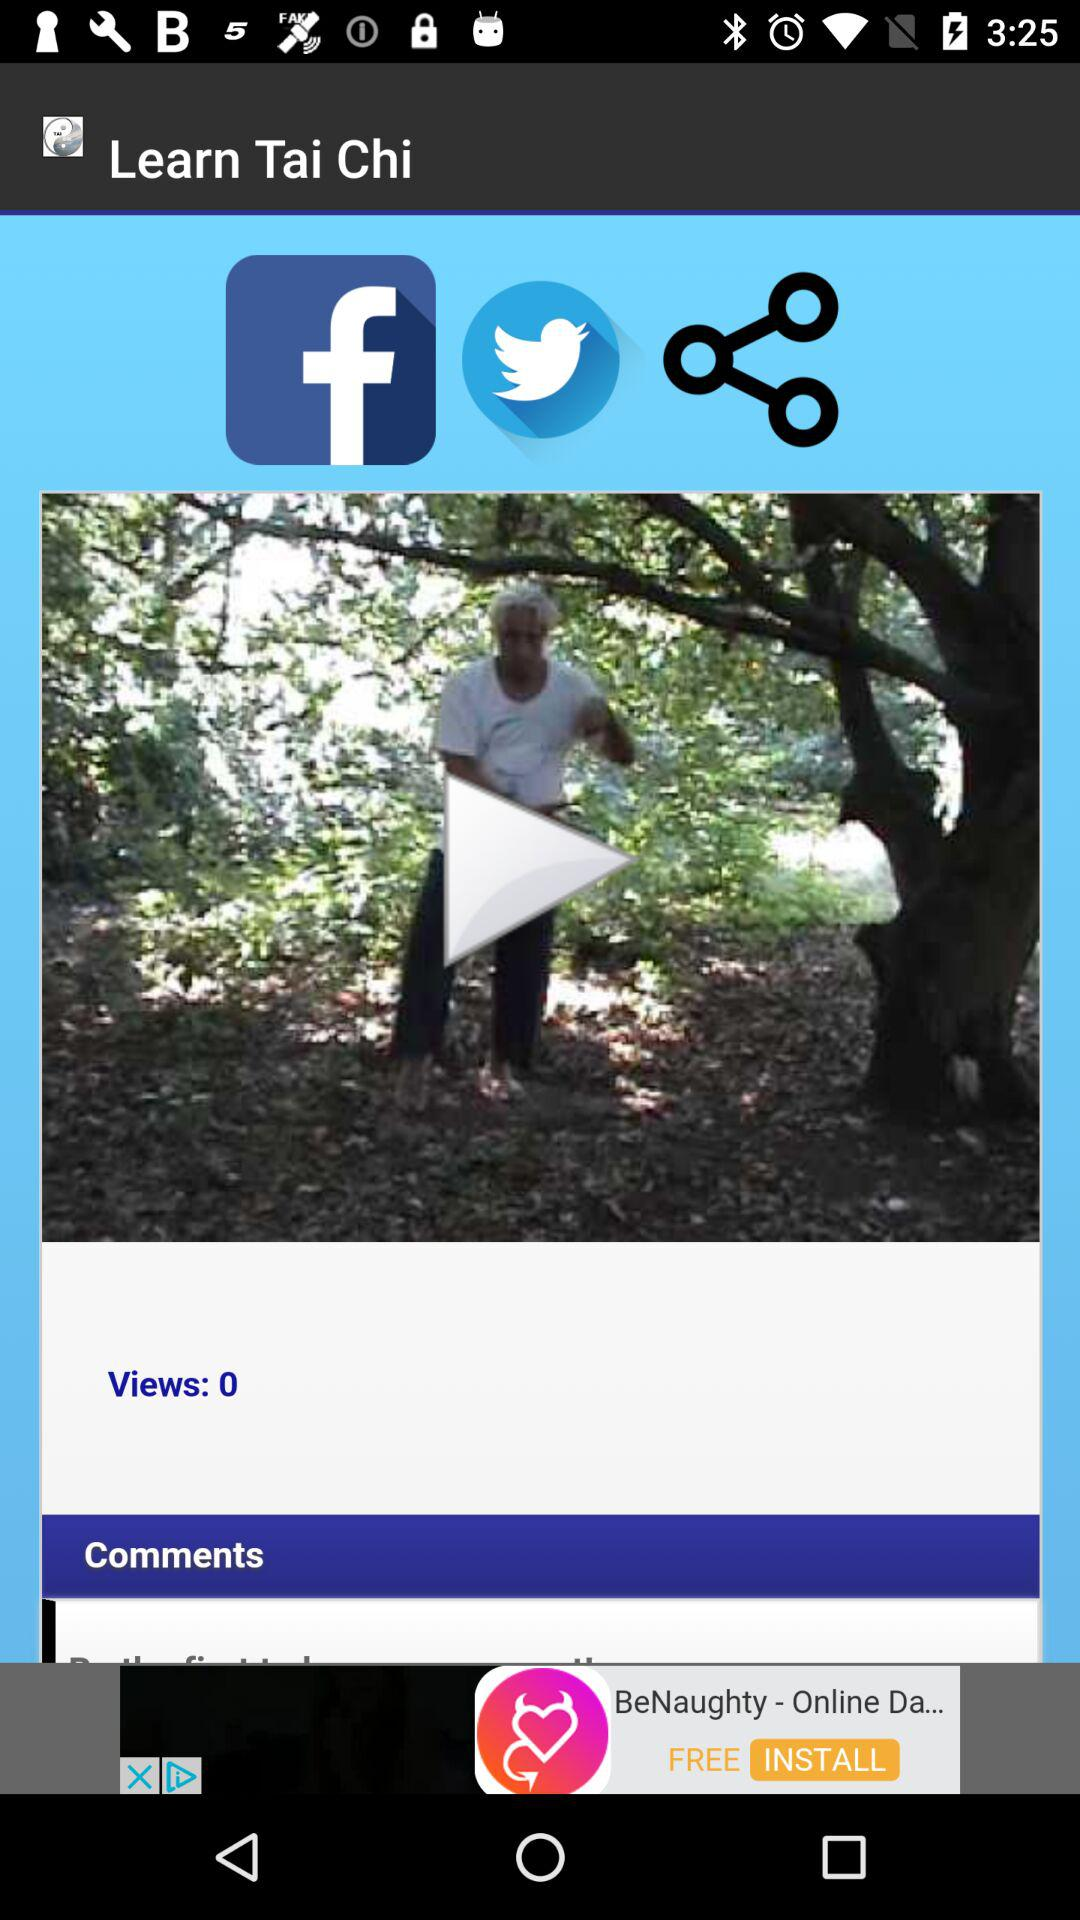How many views are there? There are 0 views. 